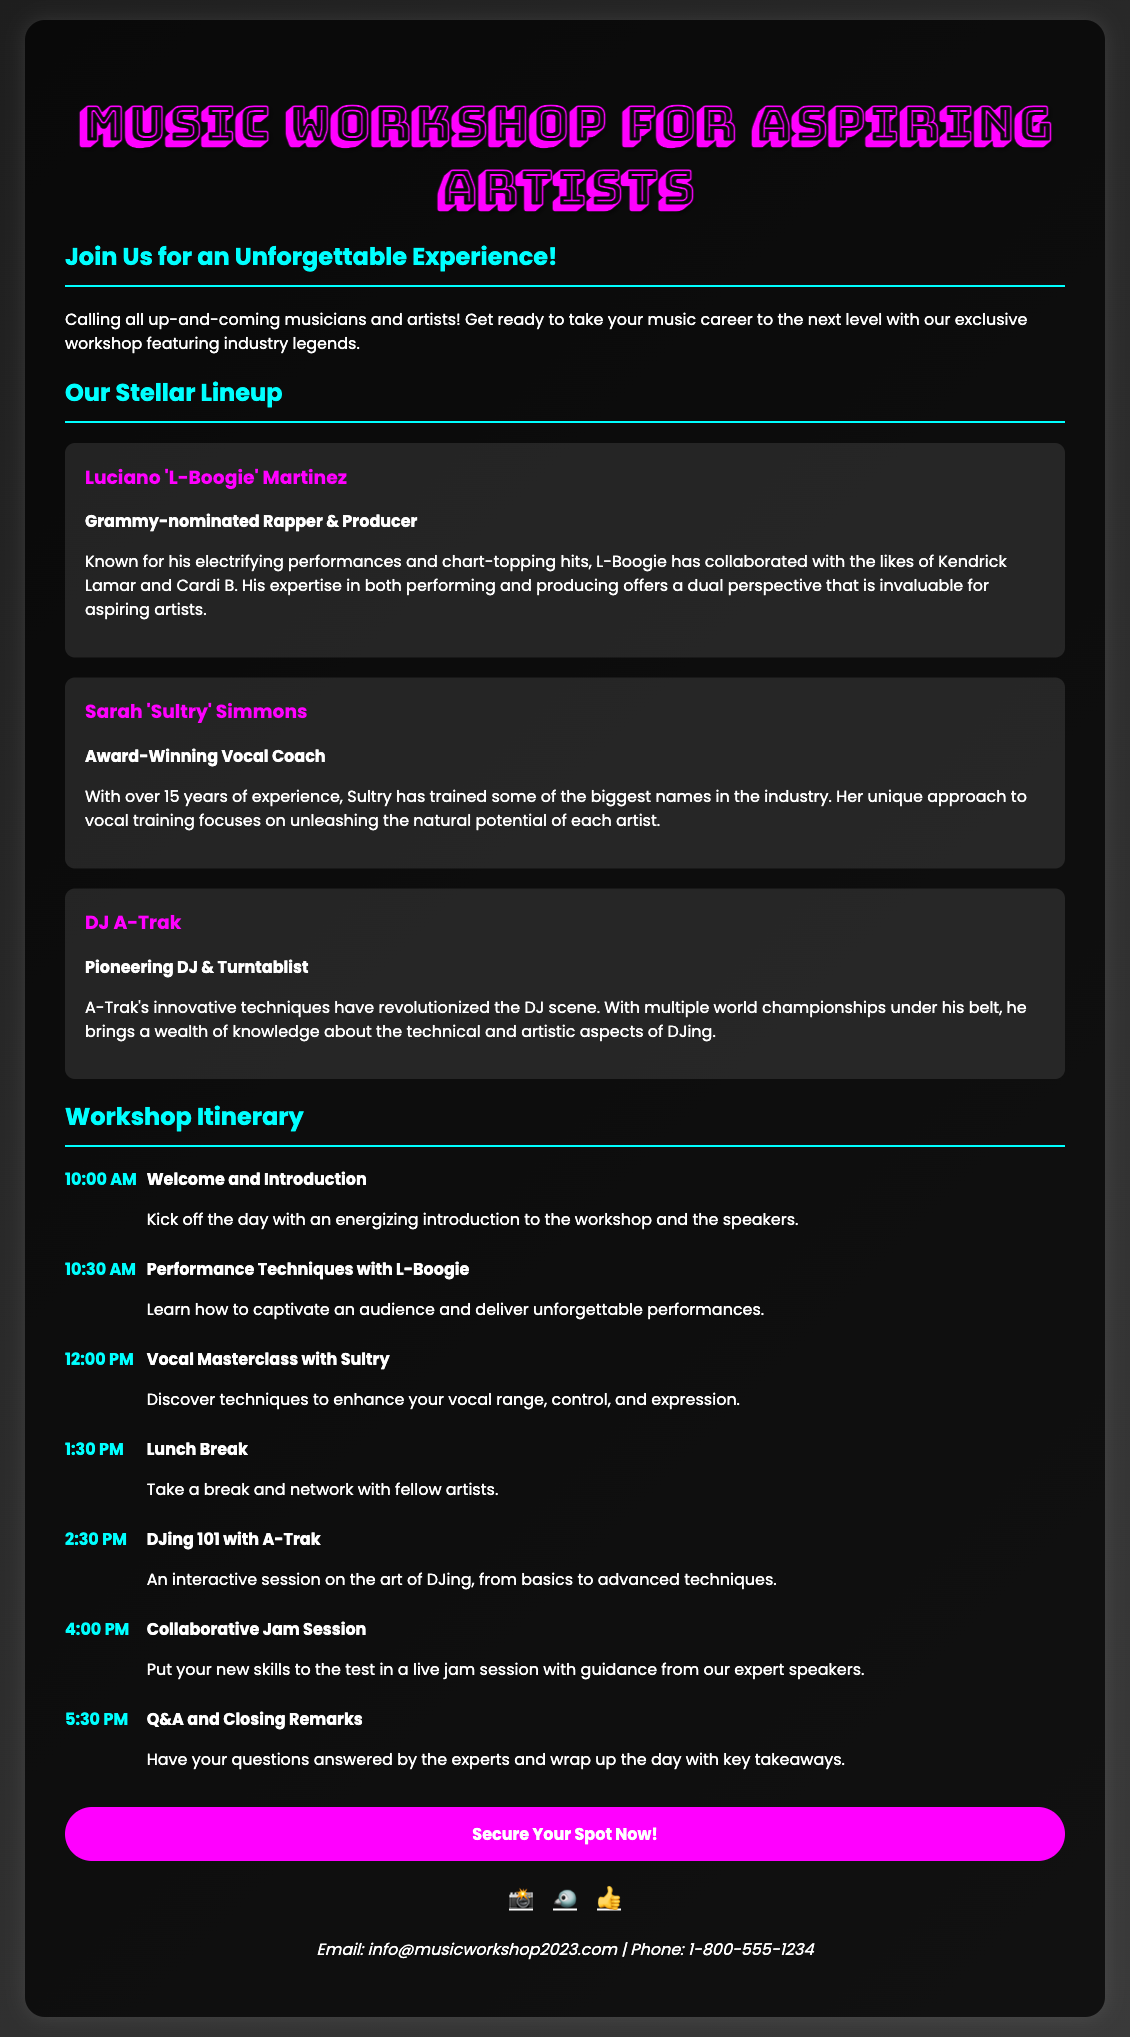What is the title of the workshop? The title of the workshop is prominently displayed at the top of the document.
Answer: Music Workshop for Aspiring Artists Who are the headline speakers? The document lists three main speakers with details about their backgrounds and expertise.
Answer: Luciano 'L-Boogie' Martinez, Sarah 'Sultry' Simmons, DJ A-Trak What time does the workshop start? The itinerary specifies the time the workshop begins.
Answer: 10:00 AM How long is the lunch break scheduled to last? The itinerary outlines the timing for the break.
Answer: 1 hour What is the main activity during the collaborative session? The document describes the nature of the collaborative activity scheduled in the itinerary.
Answer: Live jam session Which social media platforms are linked in the document? The social links section lists specific social media platforms with corresponding icons.
Answer: Instagram, Twitter, Facebook What is the RSVP link for securing a spot? The document provides a clear call-to-action with a specific URL for RSVP.
Answer: http://musicworkshop2023.com/rsvp How many years of experience does Sultry have? The text mentions the number of years of experience Sultry has in her field.
Answer: 15 years 